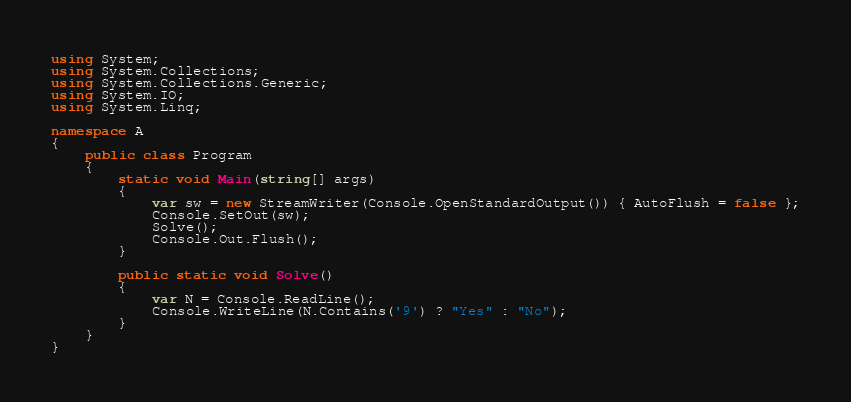Convert code to text. <code><loc_0><loc_0><loc_500><loc_500><_C#_>using System;
using System.Collections;
using System.Collections.Generic;
using System.IO;
using System.Linq;

namespace A
{
    public class Program
    {
        static void Main(string[] args)
        {
            var sw = new StreamWriter(Console.OpenStandardOutput()) { AutoFlush = false };
            Console.SetOut(sw);
            Solve();
            Console.Out.Flush();
        }

        public static void Solve()
        {
            var N = Console.ReadLine();
            Console.WriteLine(N.Contains('9') ? "Yes" : "No");
        }
    }
}
</code> 